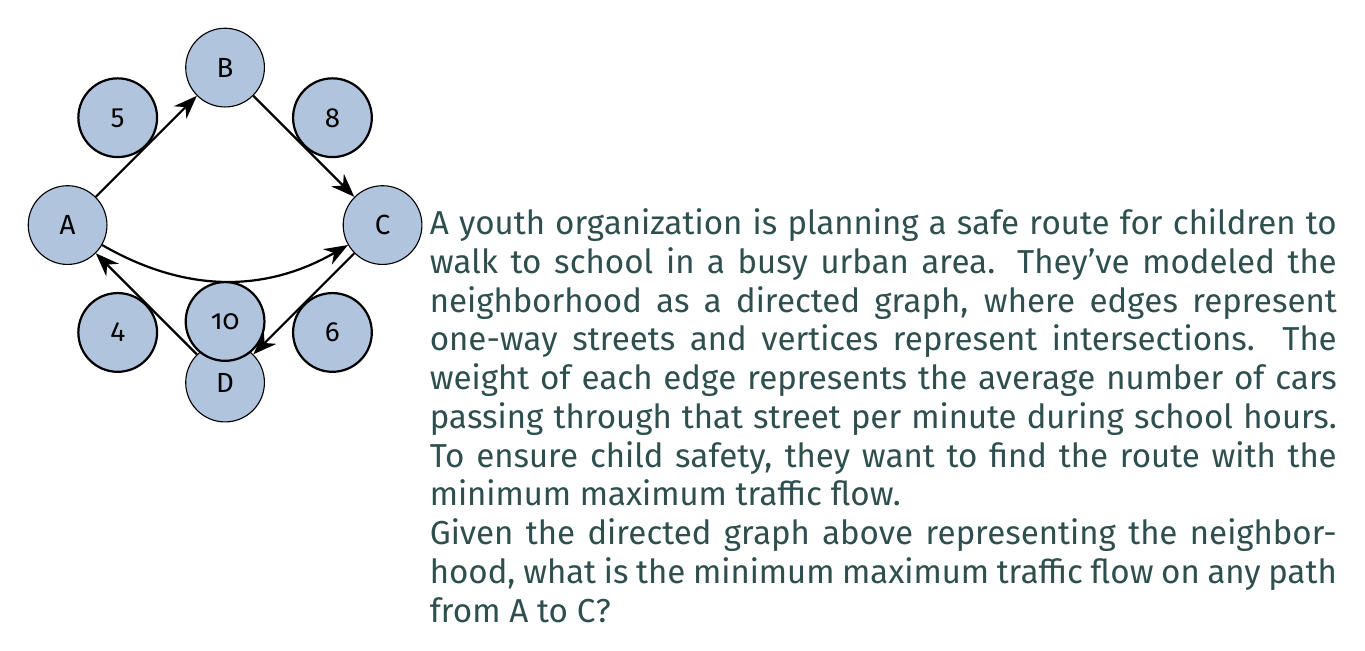Show me your answer to this math problem. To solve this problem, we need to find all possible paths from A to C and determine the maximum traffic flow (weight) on each path. Then, we choose the path with the minimum of these maximum flows.

Let's identify all paths from A to C:

1. A → B → C
2. A → C (direct)
3. A → D → A → C (this path contains a cycle, but we'll consider it for completeness)

Now, let's analyze each path:

1. A → B → C
   Maximum flow: $\max(5, 8) = 8$

2. A → C (direct)
   Maximum flow: $10$

3. A → D → A → C
   Maximum flow: $\max(4, 4, 10) = 10$

The minimum of these maximum flows is 8, which occurs on the path A → B → C.

This approach is an application of the minimax path algorithm, which is used to find the path that minimizes the maximum edge weight along the path. In the context of our problem, this ensures that children are exposed to the least amount of heavy traffic possible on their route to school.
Answer: The minimum maximum traffic flow on any path from A to C is 8 cars per minute, achieved by the path A → B → C. 